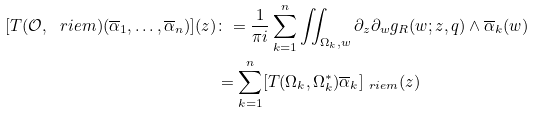Convert formula to latex. <formula><loc_0><loc_0><loc_500><loc_500>[ T ( \mathcal { O } , \ r i e m ) ( \overline { \alpha } _ { 1 } , \dots , \overline { \alpha } _ { n } ) ] ( z ) & \colon = \frac { 1 } { \pi i } \sum _ { k = 1 } ^ { n } \iint _ { \Omega _ { k } , w } \partial _ { z } \partial _ { w } g _ { R } ( w ; z , q ) \wedge \overline { \alpha } _ { k } ( w ) \\ & = \sum _ { k = 1 } ^ { n } [ T ( \Omega _ { k } , \Omega ^ { * } _ { k } ) \overline { \alpha } _ { k } ] _ { \ r i e m } ( z )</formula> 